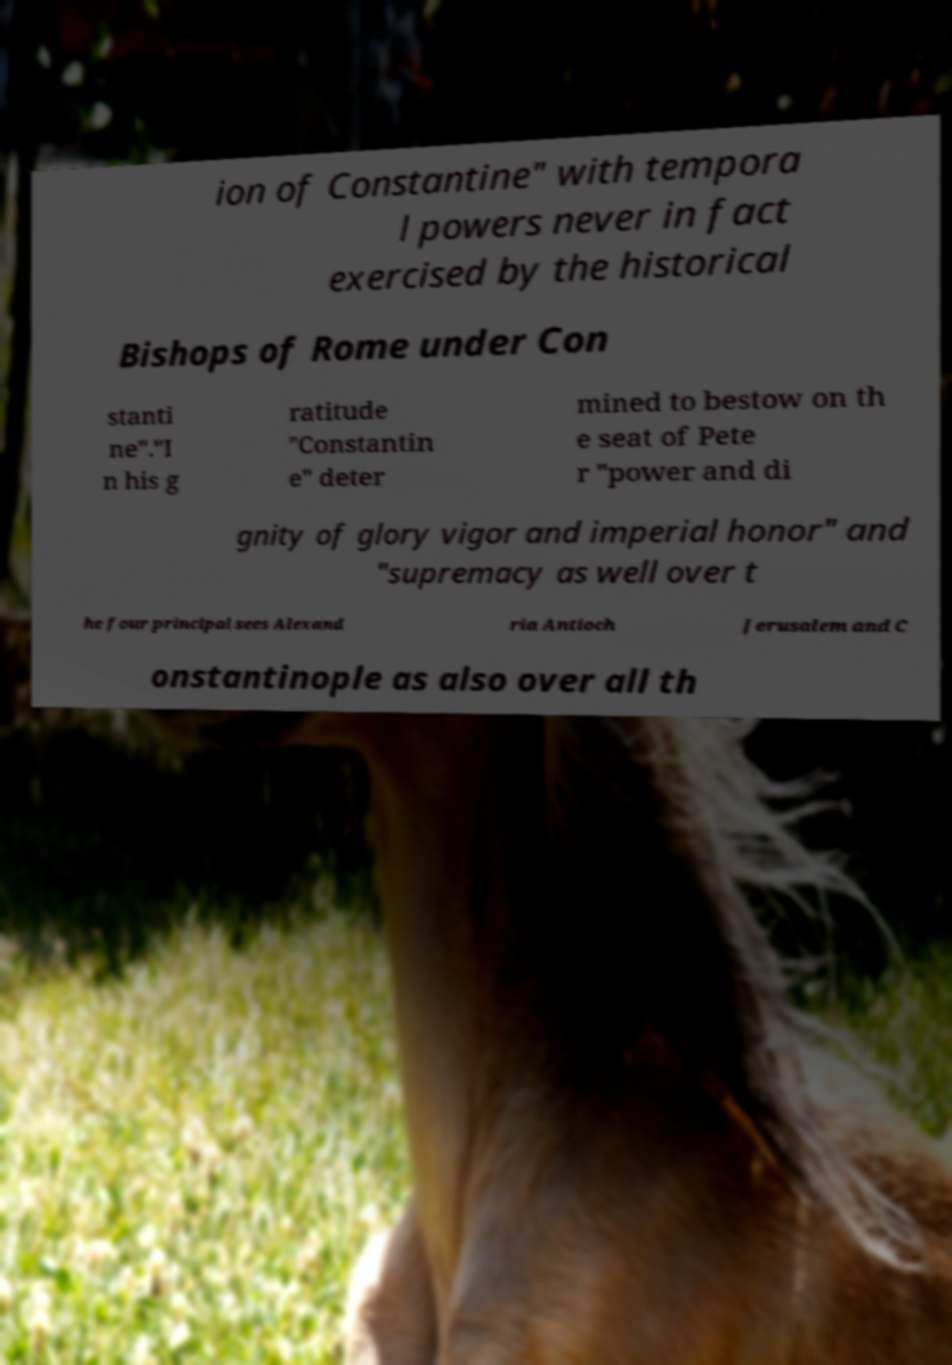What messages or text are displayed in this image? I need them in a readable, typed format. ion of Constantine" with tempora l powers never in fact exercised by the historical Bishops of Rome under Con stanti ne"."I n his g ratitude "Constantin e" deter mined to bestow on th e seat of Pete r "power and di gnity of glory vigor and imperial honor" and "supremacy as well over t he four principal sees Alexand ria Antioch Jerusalem and C onstantinople as also over all th 